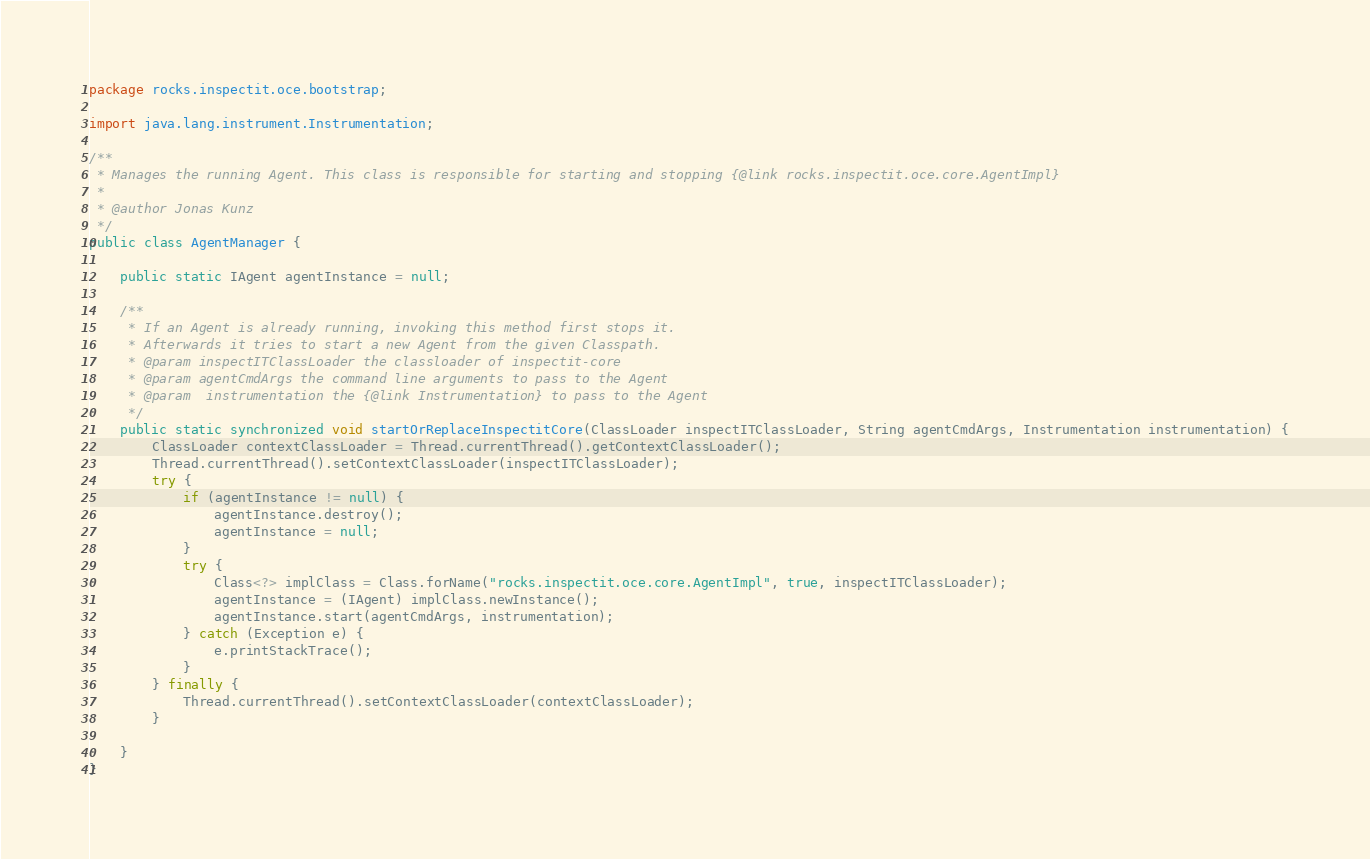<code> <loc_0><loc_0><loc_500><loc_500><_Java_>package rocks.inspectit.oce.bootstrap;

import java.lang.instrument.Instrumentation;

/**
 * Manages the running Agent. This class is responsible for starting and stopping {@link rocks.inspectit.oce.core.AgentImpl}
 *
 * @author Jonas Kunz
 */
public class AgentManager {

    public static IAgent agentInstance = null;

    /**
     * If an Agent is already running, invoking this method first stops it.
     * Afterwards it tries to start a new Agent from the given Classpath.
     * @param inspectITClassLoader the classloader of inspectit-core
     * @param agentCmdArgs the command line arguments to pass to the Agent
     * @param  instrumentation the {@link Instrumentation} to pass to the Agent
     */
    public static synchronized void startOrReplaceInspectitCore(ClassLoader inspectITClassLoader, String agentCmdArgs, Instrumentation instrumentation) {
        ClassLoader contextClassLoader = Thread.currentThread().getContextClassLoader();
        Thread.currentThread().setContextClassLoader(inspectITClassLoader);
        try {
            if (agentInstance != null) {
                agentInstance.destroy();
                agentInstance = null;
            }
            try {
                Class<?> implClass = Class.forName("rocks.inspectit.oce.core.AgentImpl", true, inspectITClassLoader);
                agentInstance = (IAgent) implClass.newInstance();
                agentInstance.start(agentCmdArgs, instrumentation);
            } catch (Exception e) {
                e.printStackTrace();
            }
        } finally {
            Thread.currentThread().setContextClassLoader(contextClassLoader);
        }

    }
}
</code> 